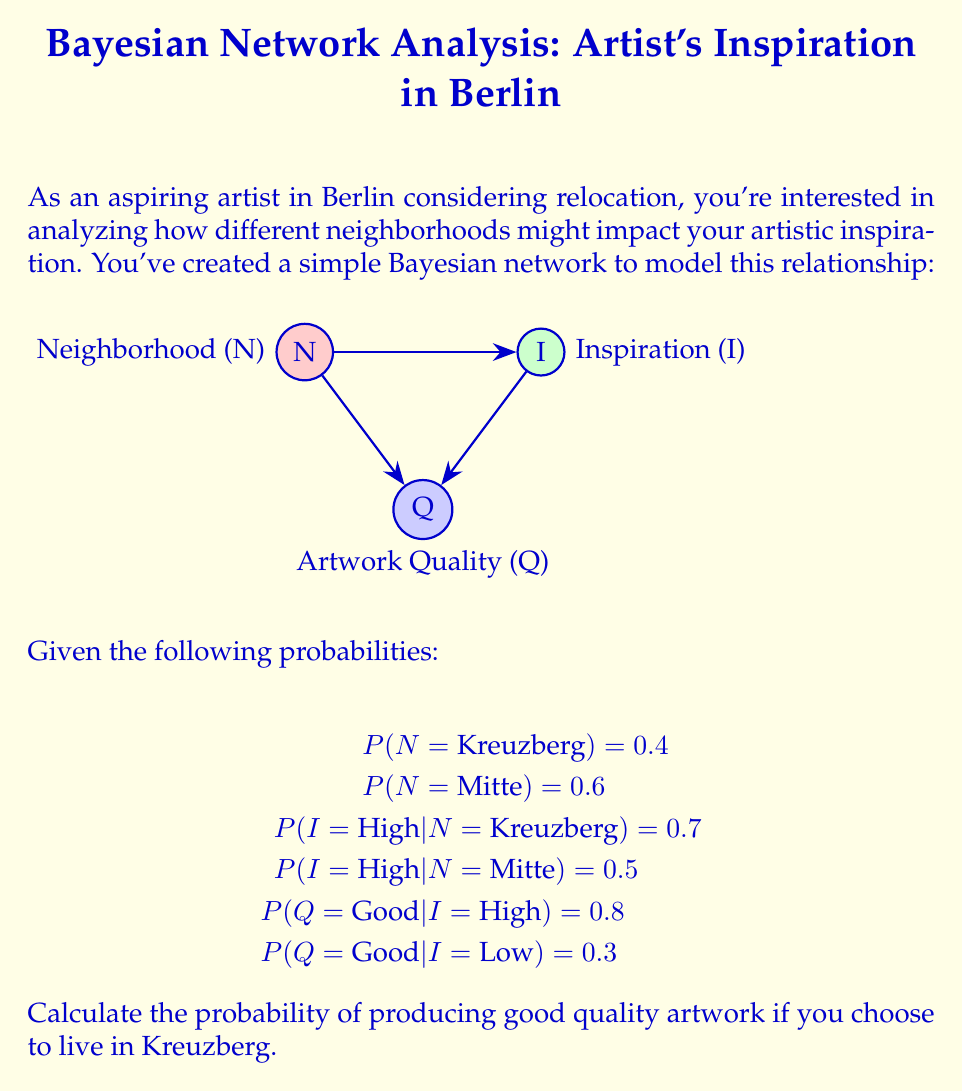Solve this math problem. To solve this problem, we'll use the law of total probability and Bayes' theorem. We need to calculate $P(Q = \text{Good} | N = \text{Kreuzberg})$.

Step 1: Use the law of total probability to break down the probability based on inspiration levels.

$$P(Q = \text{Good} | N = \text{Kreuzberg}) = P(Q = \text{Good} | I = \text{High}) \cdot P(I = \text{High} | N = \text{Kreuzberg}) + P(Q = \text{Good} | I = \text{Low}) \cdot P(I = \text{Low} | N = \text{Kreuzberg})$$

Step 2: We know $P(Q = \text{Good} | I = \text{High}) = 0.8$ and $P(I = \text{High} | N = \text{Kreuzberg}) = 0.7$. We need to calculate $P(I = \text{Low} | N = \text{Kreuzberg})$.

$$P(I = \text{Low} | N = \text{Kreuzberg}) = 1 - P(I = \text{High} | N = \text{Kreuzberg}) = 1 - 0.7 = 0.3$$

Step 3: Now we can plug in all the values:

$$P(Q = \text{Good} | N = \text{Kreuzberg}) = 0.8 \cdot 0.7 + 0.3 \cdot 0.3$$

Step 4: Calculate the final probability:

$$P(Q = \text{Good} | N = \text{Kreuzberg}) = 0.56 + 0.09 = 0.65$$

Therefore, the probability of producing good quality artwork if you choose to live in Kreuzberg is 0.65 or 65%.
Answer: 0.65 